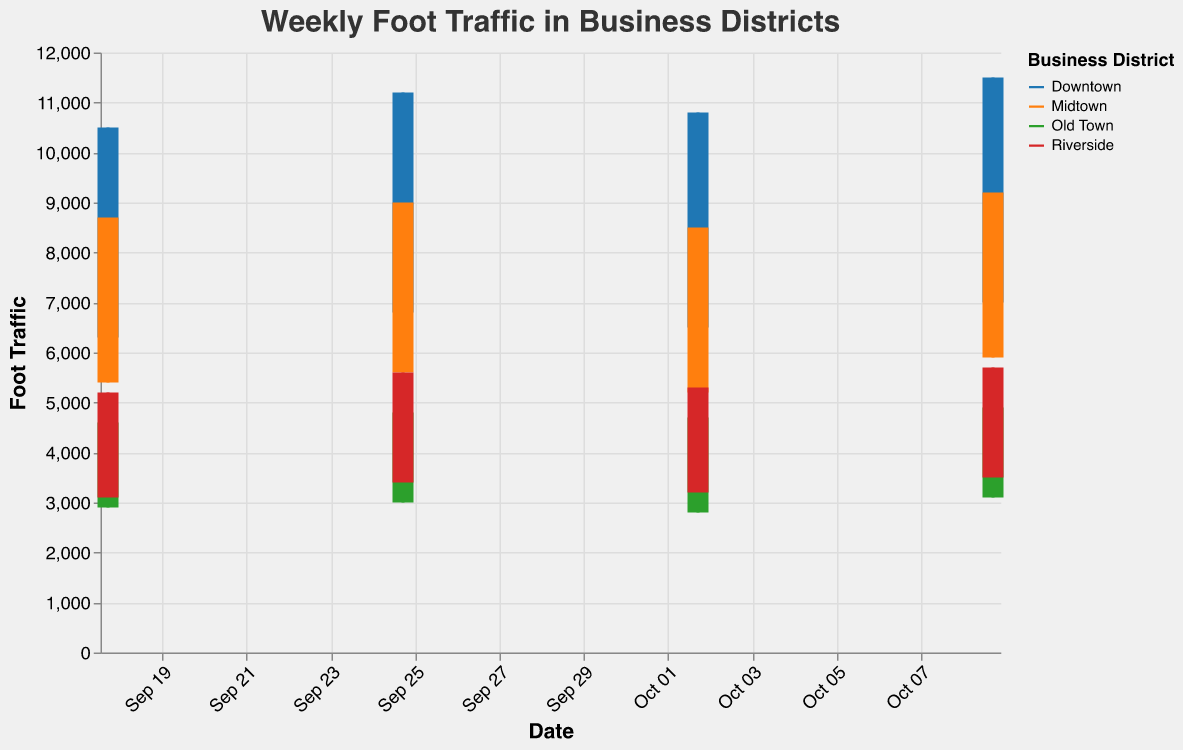How many different business districts are shown in the figure? The plot uses different colors to represent each business district. By counting these different color legends, one can determine there are four districts.
Answer: Four What are the dates represented in the figure? The x-axis shows the date labels. By reading through these, we can see the dates are September 18, September 25, October 2, and October 9, 2023.
Answer: September 18, September 25, October 2, October 9 Which business district had the highest daily high foot traffic on October 9, 2023? By observing the height of the bars on October 9, 2023, the tallest bar corresponds to the Downtown district with a daily high of 11,500.
Answer: Downtown What is the range of foot traffic in Riverside on September 25, 2023? On September 25, 2023, the Riverside district shows a daily high of 5,600 and a daily low of 3,400. The range is calculated by subtracting the daily low from the daily high, which is 5,600 - 3,400.
Answer: 2,200 Which business district shows the smallest difference between daily high and daily low on October 2, 2023? Calculate the difference for each district on October 2. Downtown: 10800-6500 = 4300, Midtown: 8500-5200 = 3300, Old Town: 4700-2800 = 1900, Riverside: 5300-3200 = 2100. The smallest difference is for Old Town with 1900.
Answer: Old Town How did the foot traffic in Midtown change from September 18 to October 9? By comparing the daily high and daily low for Midtown on these dates, on September 18: 8700 - 5400, and October 9: 9200 - 5900, we can see there is an increase of 500 in both high and low values.
Answer: Increased by 500 On which date did Downtown experience the highest daily foot traffic? Look for the highest bar representing Downtown across all dates. The highest daily foot traffic for Downtown is on October 9, 2023, with 11,500.
Answer: October 9 Which business district shows the most consistent foot traffic over the four weeks? Assess consistency by observing the fluctuations in bar heights and rule extents over time. The Old Town district has the smallest and most consistent range over the four weeks as evidenced by less variation.
Answer: Old Town What was the average daily high foot traffic in Riverside over the four weeks? Sum the daily high values of Riverside: 5200 + 5600 + 5300 + 5700 = 21800. Then, divide by the number of weeks (4): 21800/4.
Answer: 5,450 